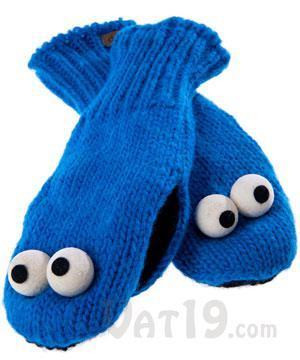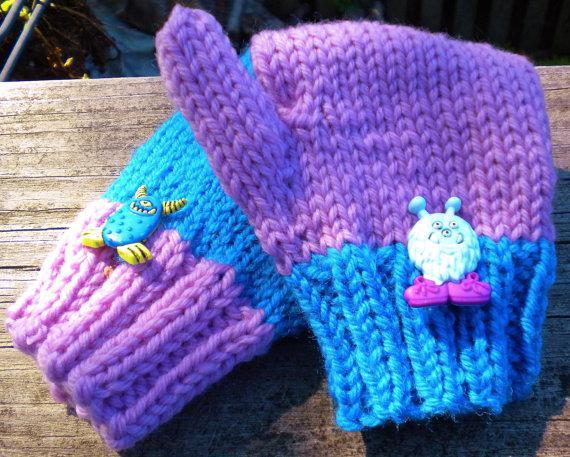The first image is the image on the left, the second image is the image on the right. Evaluate the accuracy of this statement regarding the images: "there are at least two pairs of mittens in the image on the left". Is it true? Answer yes or no. No. The first image is the image on the left, the second image is the image on the right. Given the left and right images, does the statement "An image shows one pair of blue mittens with cartoon-like eyes, and no other mittens." hold true? Answer yes or no. Yes. The first image is the image on the left, the second image is the image on the right. Assess this claim about the two images: "One image shows a single pair of blue gloves that are not furry.". Correct or not? Answer yes or no. Yes. 